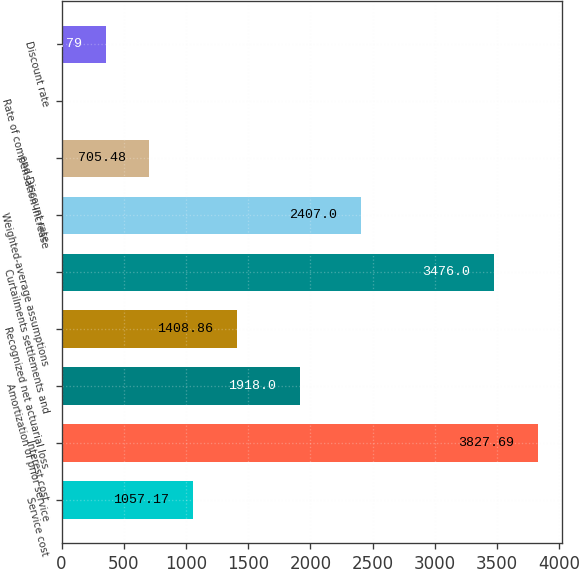Convert chart. <chart><loc_0><loc_0><loc_500><loc_500><bar_chart><fcel>Service cost<fcel>Interest cost<fcel>Amortization of prior service<fcel>Recognized net actuarial loss<fcel>Curtailments settlements and<fcel>Weighted-average assumptions<fcel>end Discount rate<fcel>Rate of compensation increase<fcel>Discount rate<nl><fcel>1057.17<fcel>3827.69<fcel>1918<fcel>1408.86<fcel>3476<fcel>2407<fcel>705.48<fcel>2.1<fcel>353.79<nl></chart> 